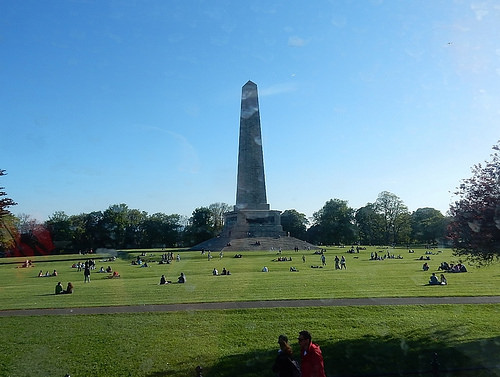<image>
Is there a monument behind the grass? Yes. From this viewpoint, the monument is positioned behind the grass, with the grass partially or fully occluding the monument. 